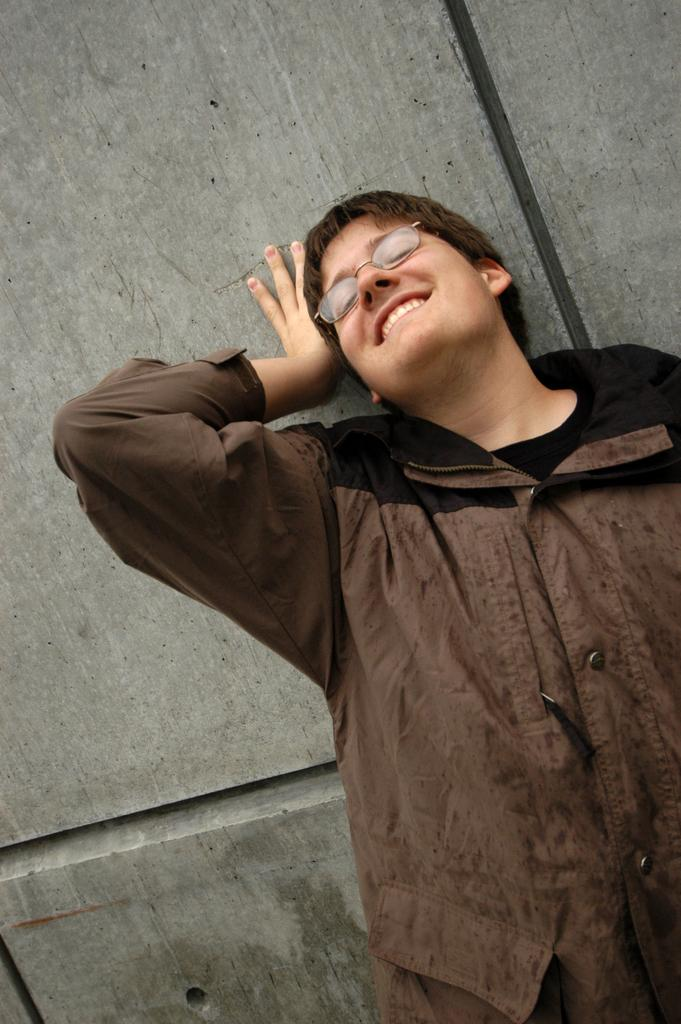What is the main subject in the foreground of the picture? There is a person in the foreground of the picture. What is the person doing in the picture? The person is smiling in the picture. What is the position of the person in the picture? The person is standing in the picture. What can be seen in the background of the picture? There is an object in the background of the picture. What type of door can be seen in the picture? There is no door present in the picture; it only features a person in the foreground and an object in the background. 